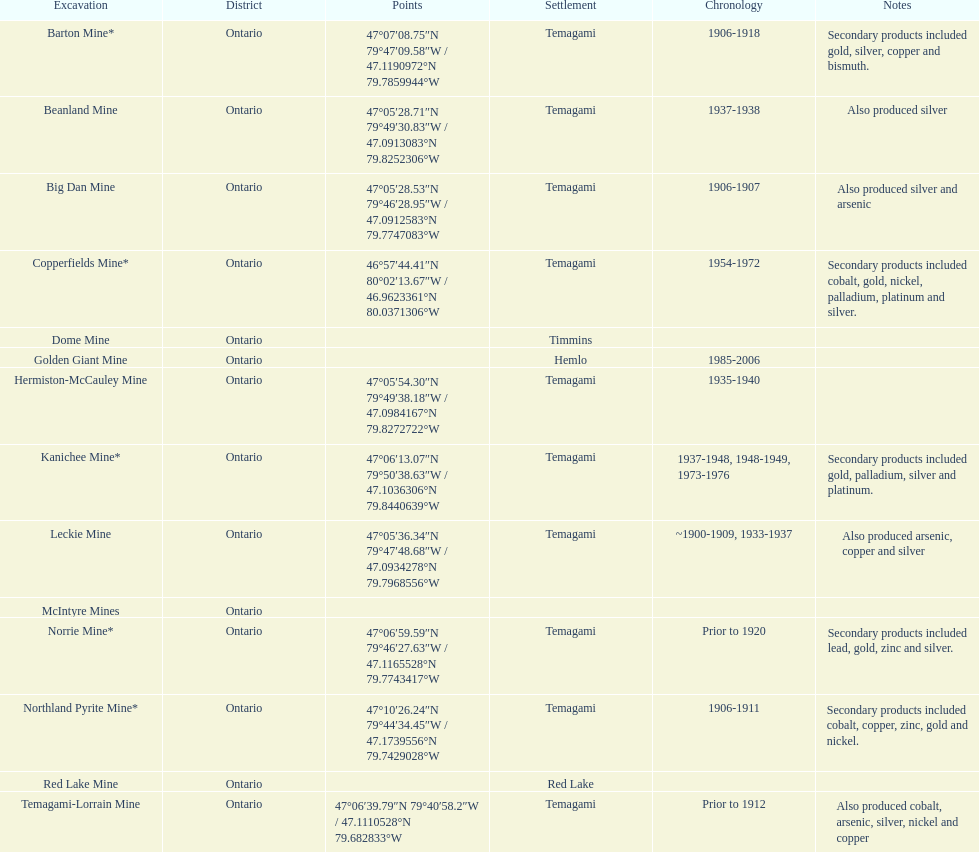In what mine could you find bismuth? Barton Mine. 